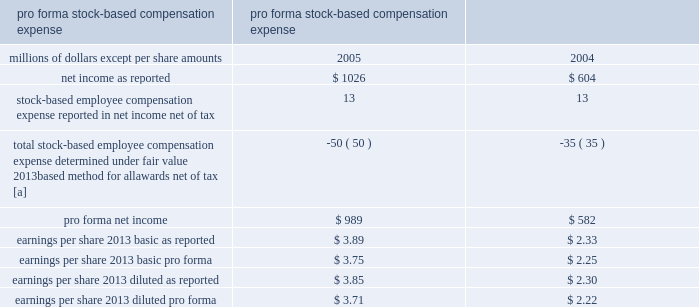Stock-based compensation 2013 we have several stock-based compensation plans under which employees and non-employee directors receive stock options , nonvested retention shares , and nonvested stock units .
We refer to the nonvested shares and stock units collectively as 201cretention awards 201d .
We issue treasury shares to cover option exercises and stock unit vestings , while new shares are issued when retention shares vest .
We adopted fasb statement no .
123 ( r ) , share-based payment ( fas 123 ( r ) ) , on january 1 , 2006 .
Fas 123 ( r ) requires us to measure and recognize compensation expense for all stock-based awards made to employees and directors , including stock options .
Compensation expense is based on the calculated fair value of the awards as measured at the grant date and is expensed ratably over the service period of the awards ( generally the vesting period ) .
The fair value of retention awards is the stock price on the date of grant , while the fair value of stock options is determined by using the black-scholes option pricing model .
We elected to use the modified prospective transition method as permitted by fas 123 ( r ) and did not restate financial results for prior periods .
We did not make an adjustment for the cumulative effect of these estimated forfeitures , as the impact was not material .
As a result of the adoption of fas 123 ( r ) , we recognized expense for stock options in 2006 , in addition to retention awards , which were expensed prior to 2006 .
Stock-based compensation expense for the year ended december 31 , 2006 was $ 22 million , after tax , or $ 0.08 per basic and diluted share .
This includes $ 9 million for stock options and $ 13 million for retention awards for 2006 .
Before taxes , stock-based compensation expense included $ 14 million for stock options and $ 21 million for retention awards for 2006 .
We recorded $ 29 million of excess tax benefits as an inflow of financing activities in the consolidated statement of cash flows for the year ended december 31 , 2006 .
Prior to the adoption of fas 123 ( r ) , we applied the recognition and measurement principles of accounting principles board opinion no .
25 , accounting for stock issued to employees , and related interpretations .
No stock- based employee compensation expense related to stock option grants was reflected in net income , as all options granted under those plans had a grant price equal to the market value of our common stock on the date of grant .
Stock-based compensation expense related to retention shares , stock units , and other incentive plans was reflected in net income .
The table details the effect on net income and earnings per share had compensation expense for all of our stock-based awards , including stock options , been recorded in the years ended december 31 , 2005 and 2004 based on the fair value method under fasb statement no .
123 , accounting for stock-based compensation .
Pro forma stock-based compensation expense year ended december 31 , millions of dollars , except per share amounts 2005 2004 .
[a] stock options for executives granted in 2003 and 2002 included a reload feature .
This reload feature allowed executives to exercise their options using shares of union pacific corporation common stock that they already owned and obtain a new grant of options in the amount of the shares used for exercise plus any shares withheld for tax purposes .
The reload feature of these option grants could only be exercised if the .
What was the percent of the total stock based compensation in 2006 for employee retention? 
Computations: (13 / 22)
Answer: 0.59091. 